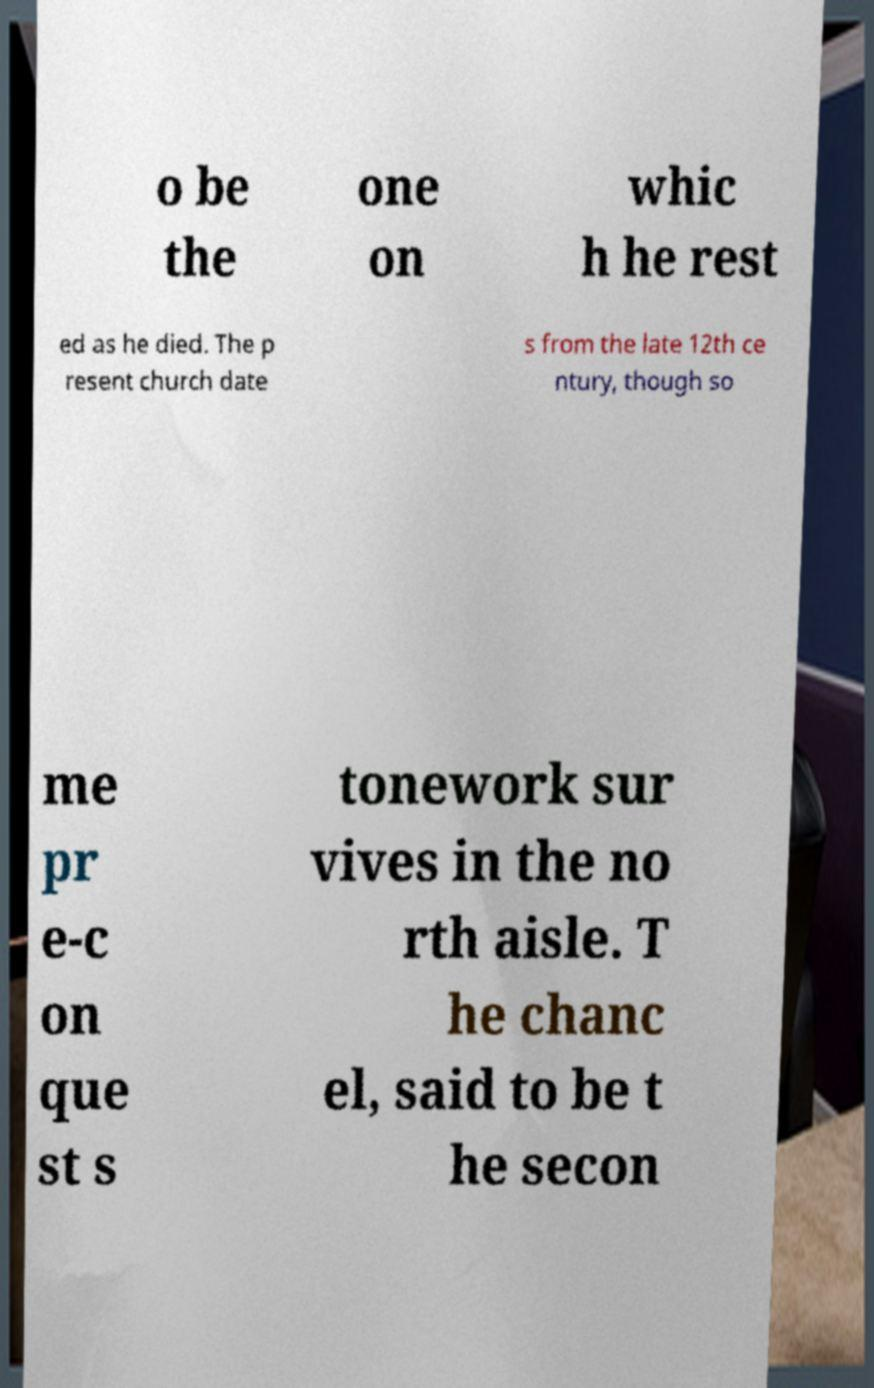Can you read and provide the text displayed in the image?This photo seems to have some interesting text. Can you extract and type it out for me? o be the one on whic h he rest ed as he died. The p resent church date s from the late 12th ce ntury, though so me pr e-c on que st s tonework sur vives in the no rth aisle. T he chanc el, said to be t he secon 